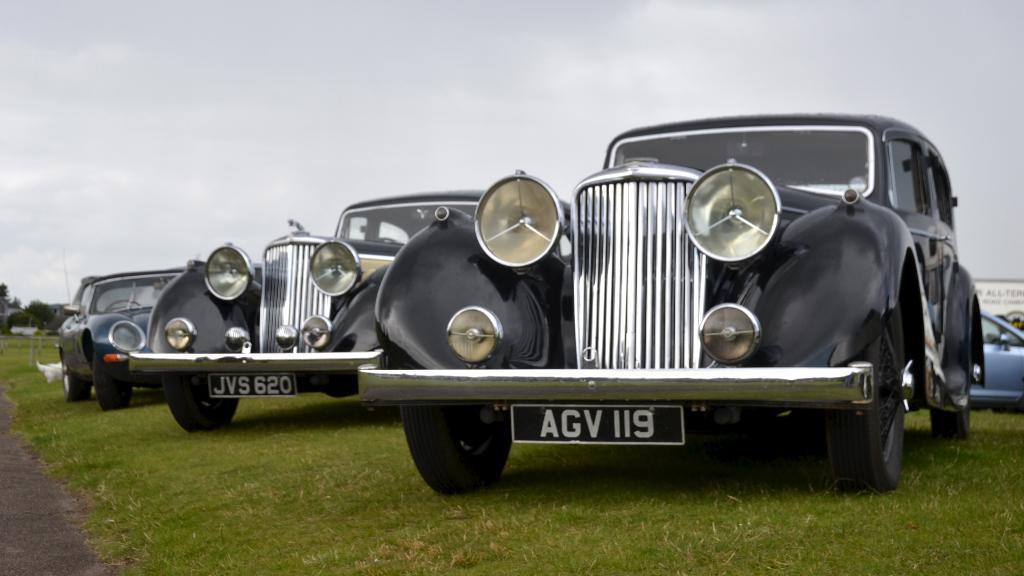Can you describe this image briefly? Here we can see vehicles on the ground. In the background there are clouds in the sky. On the left we can see tree,road and other objects and on the right we can see a hoarding. 